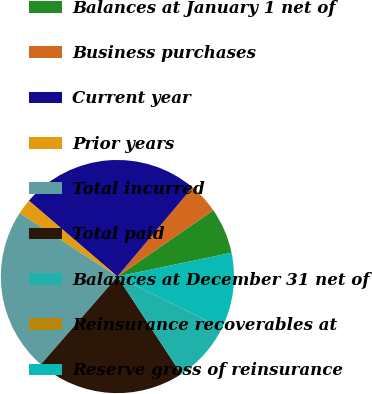<chart> <loc_0><loc_0><loc_500><loc_500><pie_chart><fcel>Balances at January 1 net of<fcel>Business purchases<fcel>Current year<fcel>Prior years<fcel>Total incurred<fcel>Total paid<fcel>Balances at December 31 net of<fcel>Reinsurance recoverables at<fcel>Reserve gross of reinsurance<nl><fcel>6.35%<fcel>4.24%<fcel>24.86%<fcel>2.12%<fcel>22.75%<fcel>20.63%<fcel>8.46%<fcel>0.01%<fcel>10.58%<nl></chart> 